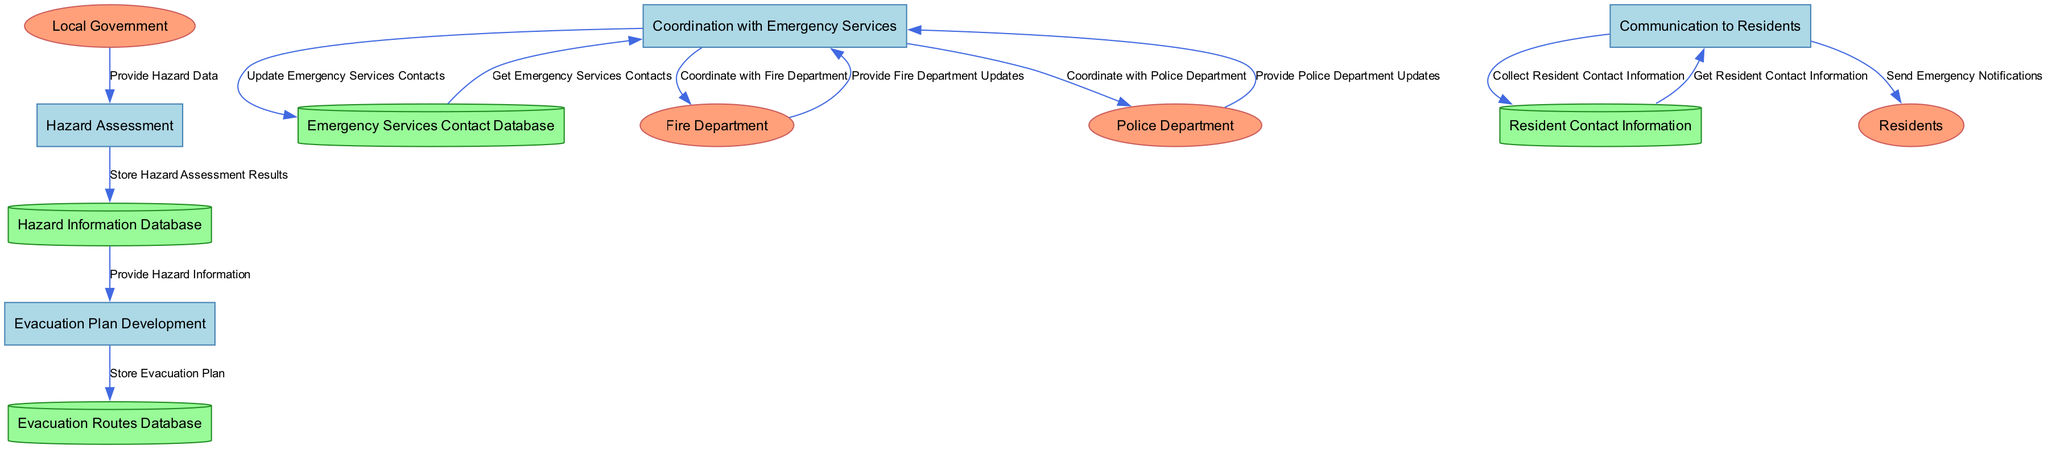What is the first process in the diagram? The diagram starts with the first process labeled "Hazard Assessment", which is identified by the node "P1".
Answer: Hazard Assessment How many data stores are present in the diagram? There are four data stores in the diagram, which are: Hazard Information Database, Evacuation Routes Database, Emergency Services Contact Database, and Resident Contact Information.
Answer: Four Which external entity provides hazard data? The external entity that provides hazard data is the "Local Government", indicated by the arrow originating from "E1" pointing to "P1".
Answer: Local Government What is the last process in the data flow? The last process in the data flow is "Communication to Residents", which is represented by the node "P4" and is the final step before sending notifications to residents.
Answer: Communication to Residents Which data store is used to collect resident contact information? The data store used to collect resident contact information is the "Resident Contact Information", denoted as "D4" in the diagram, which is linked to the process "Communication to Residents".
Answer: Resident Contact Information What is the relationship between the "Evacuation Plan Development" and "Hazard Information"? "Evacuation Plan Development" receives information from "Hazard Information Database", illustrated by the flow from "D1" to "P2", indicating that hazard information is essential for developing an evacuation plan.
Answer: Provide Hazard Information Which two external entities are coordinated with during the "Coordination with Emergency Services" process? The two external entities coordinated with during this process are the "Fire Department" and the "Police Department", represented by the arrows from "P3" to "E2" and "E3".
Answer: Fire Department and Police Department How do emergency services updates flow back to the coordination process? Emergency services updates flow back through the connections from the Fire Department and Police Department to the process "Coordination with Emergency Services", shown by data flows that return these updates to "P3".
Answer: Through data flows from Fire and Police Departments What is stored in the "Evacuation Routes Database"? The "Evacuation Routes Database" stores the evacuation plan as represented by the flow from "P2" to "D2", indicating that this database is where the plan is documented.
Answer: Evacuation Plan 